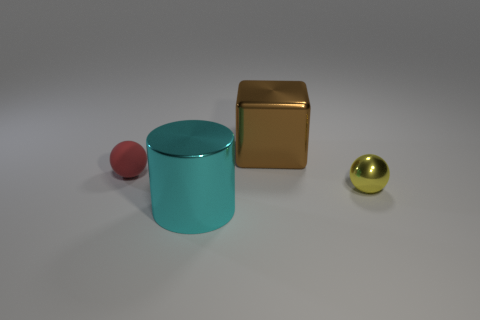What material do the objects seem to be made of? The objects in the image exhibit a reflective sheen, suggesting that they might be made of materials like polished metal or plastic with a metallic finish. 